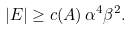Convert formula to latex. <formula><loc_0><loc_0><loc_500><loc_500>| E | \geq c ( A ) \, \alpha ^ { 4 } \beta ^ { 2 } .</formula> 